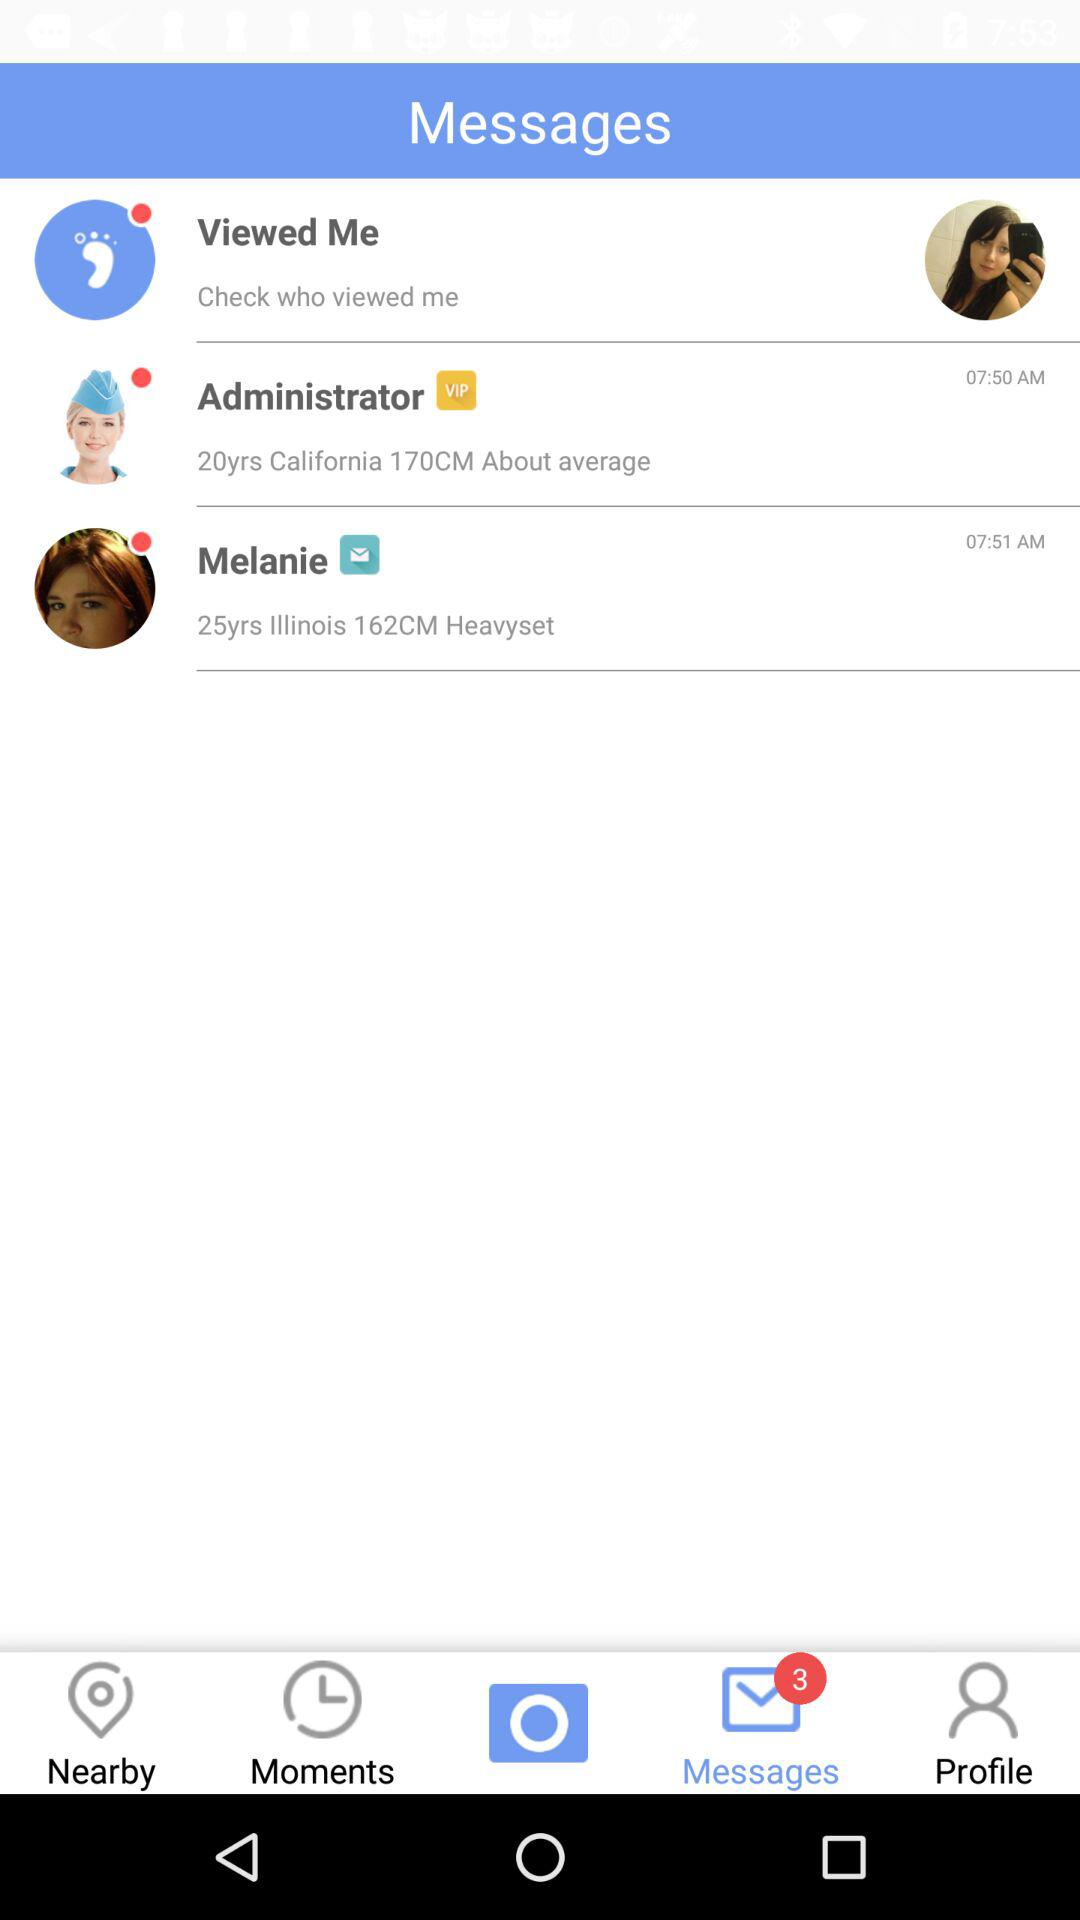How many unread messages are there? There are 3 unread messages. 